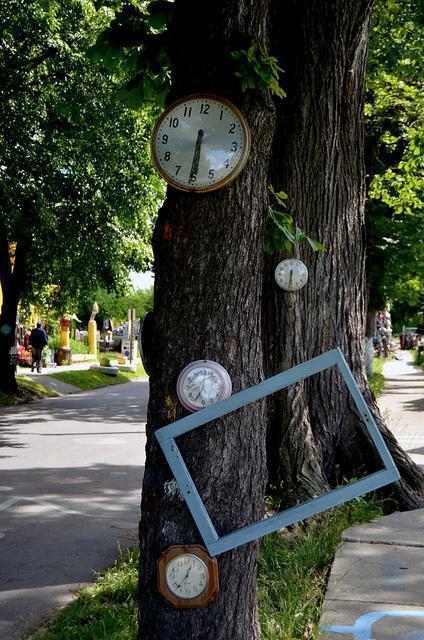What time can be seen on the highest clock?
Select the accurate answer and provide explanation: 'Answer: answer
Rationale: rationale.'
Options: Six thirty, twelve thirty, seven thirty, four thirty. Answer: six thirty.
Rationale: The time indicates six thirty. 